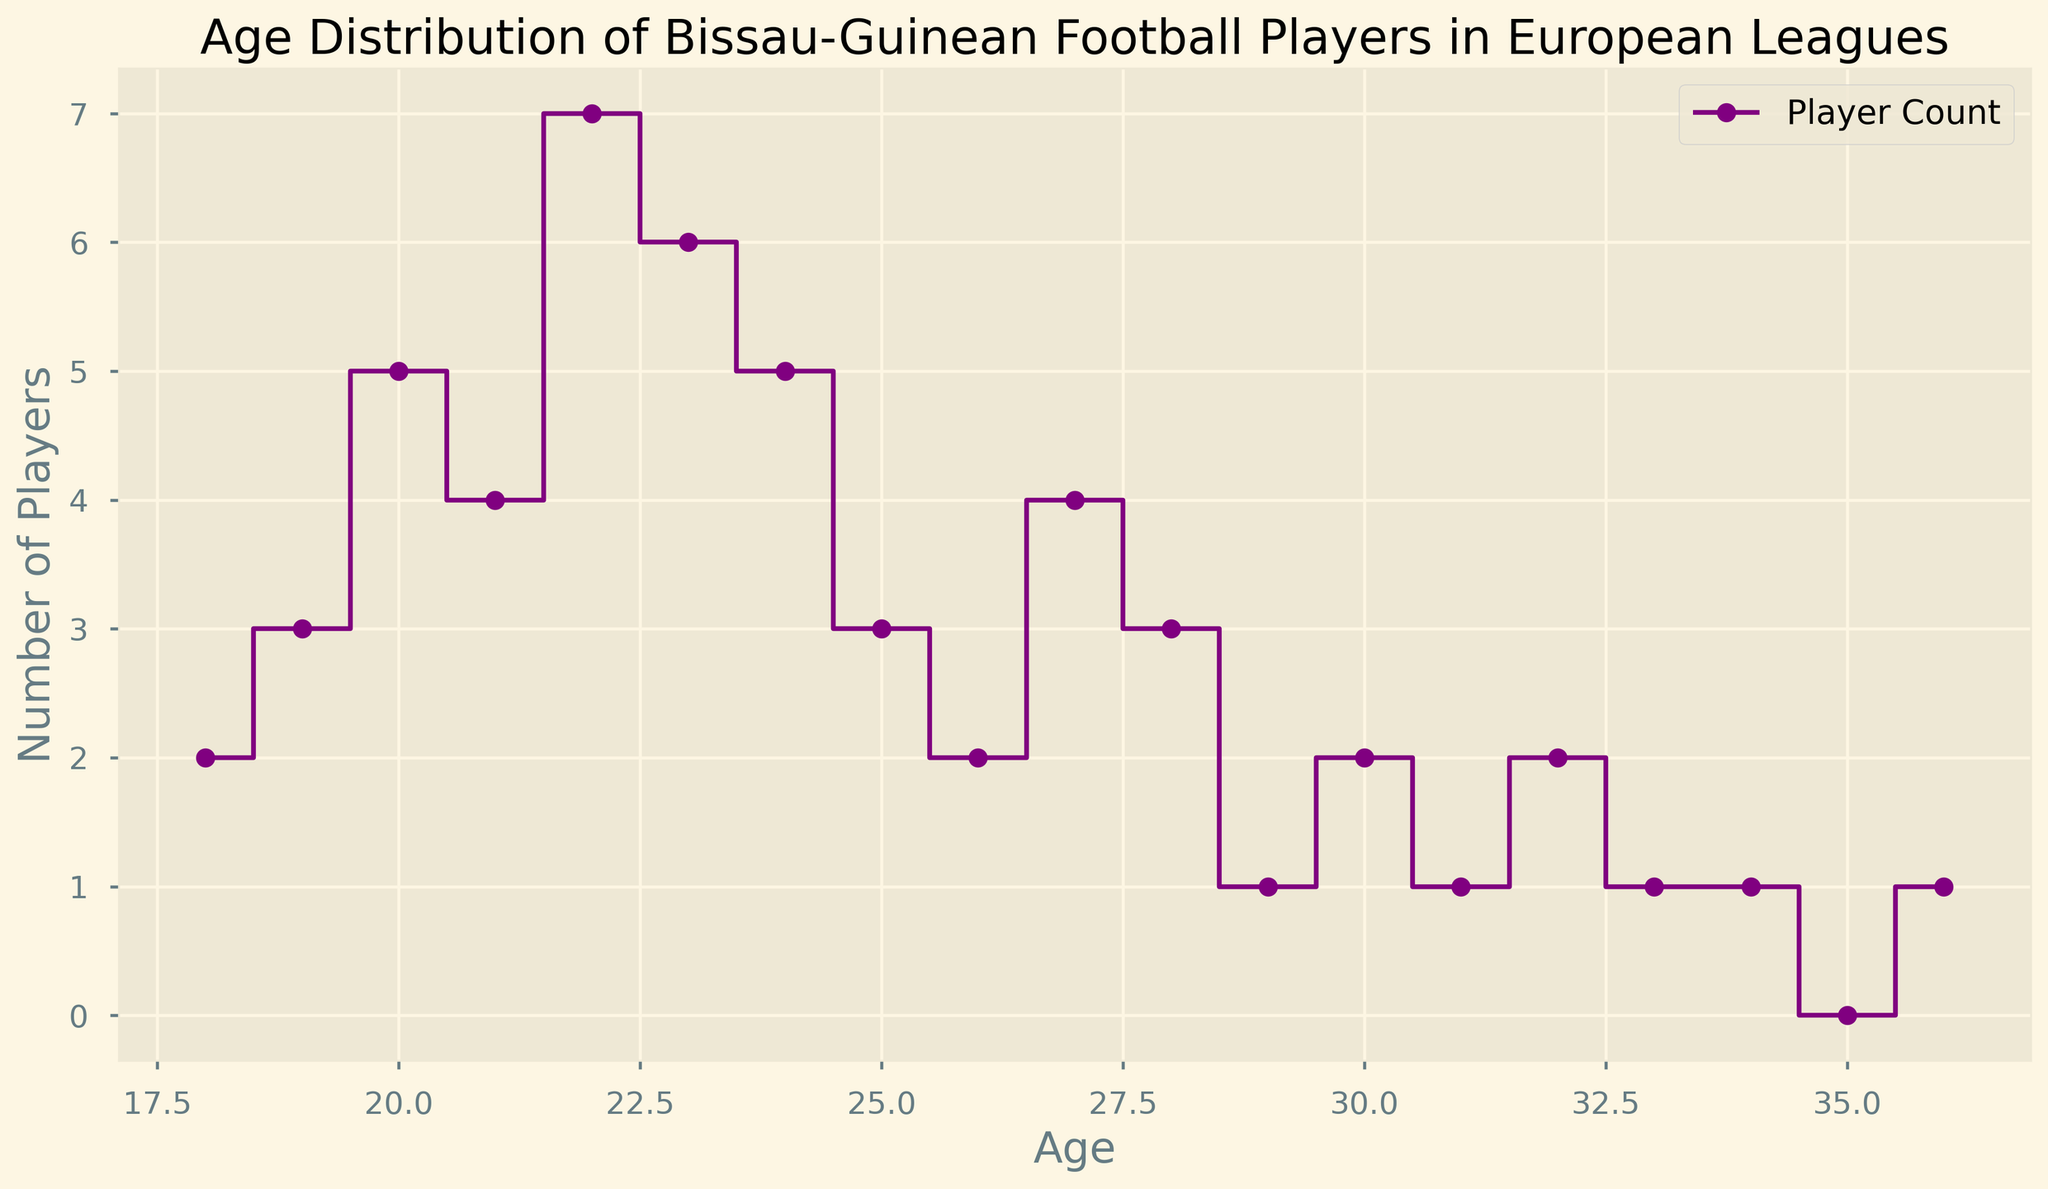How many players are in the age group of 22? The figure shows the count for age 22 as 7.
Answer: 7 Which age group has the highest number of Bissau-Guinean football players? By examining the heights of the steps in the figure, age 22 has the highest step, indicating the highest count of 7 players.
Answer: 22 Compare the number of players in age group 23 to age group 25. Which has more players? Age 23 has 6 players, while age 25 has 3 players. Therefore, age 23 has more players.
Answer: 23 What is the total number of players aged between 18 and 21 inclusive? Summing the counts for ages 18 to 21: 2 + 3 + 5 + 4 = 14.
Answer: 14 What is the difference in the number of players between the youngest and oldest age groups represented? The youngest age group (18) has 2 players, and the oldest age group (36) has 1 player. The difference is 2 - 1 = 1.
Answer: 1 What is the average number of players per age group for ages 18 to 24? Summing the counts for ages 18 to 24: 2 + 3 + 5 + 4 + 7 + 6 + 5 = 32. There are 7 age groups, so the average is 32/7 ≈ 4.57.
Answer: 4.57 How many age groups have exactly 1 player? By examining the figure, the age groups 29, 31, 33, 34, and 36 each have 1 player. There are 5 such groups.
Answer: 5 What is the trend in the number of players as age increases from 26 to 29? There is a drop from 26 to 27 (from 2 to 4), a drop from 27 to 28 (from 4 to 3), and another drop from 28 to 29 (from 3 to 1), showing a decreasing trend.
Answer: Decreasing Which age group marks the end of the most significant consecutive streak of increasing player counts? Reviewing the figure, the counts increase consecutively from age 19 (3) to age 22 (7) and decrease starting at age 23 (6). Therefore, age 22 marks the end of this streak.
Answer: 22 Do any age groups have the same number of players as age 20? If so, which ones? Age 20 has 5 players. The figure shows that age 24 also has 5 players.
Answer: 24 